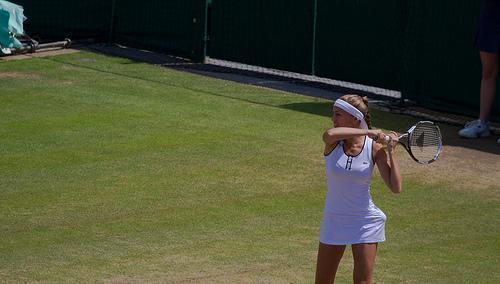How many players are in the photo?
Give a very brief answer. 1. 